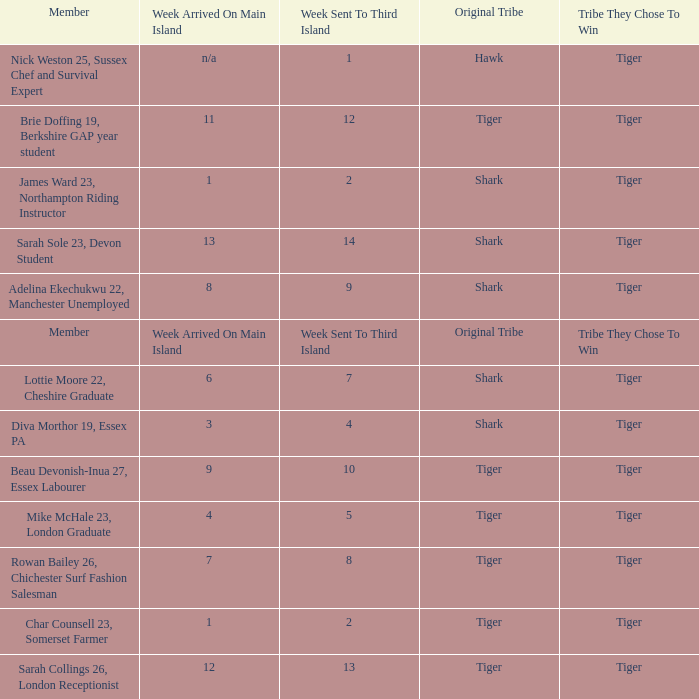What week did the member who's original tribe was shark and who was sent to the third island on week 14 arrive on the main island? 13.0. 